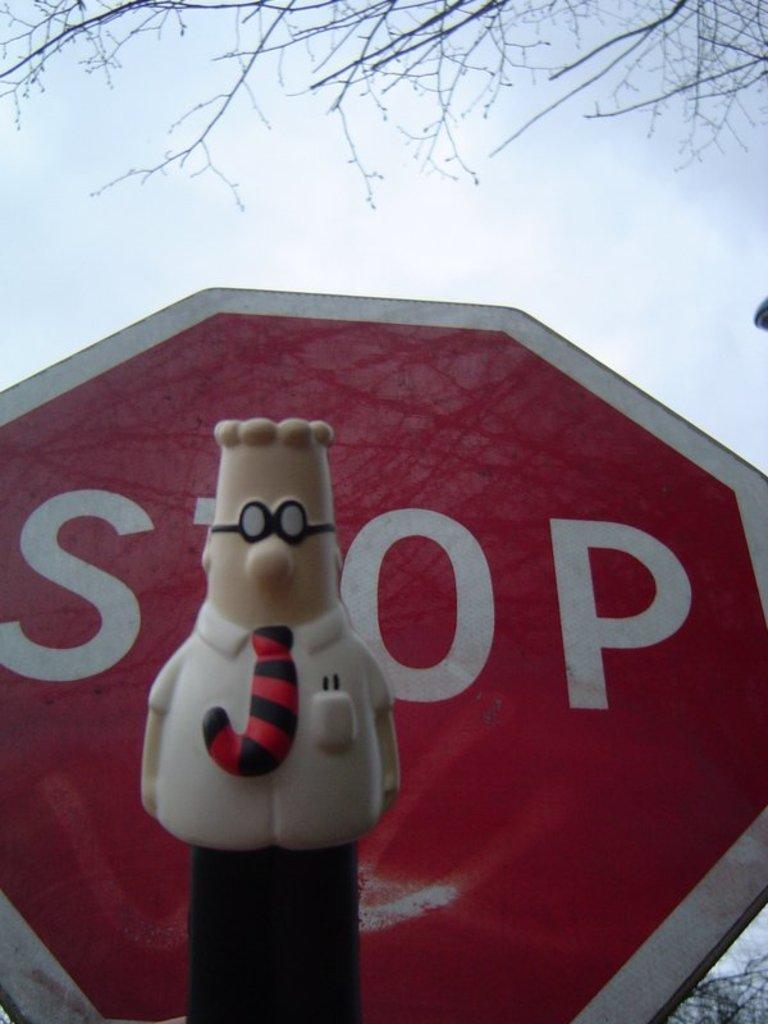In one or two sentences, can you explain what this image depicts? In this image we can see a toy and a sign board. In the background we can see branches of the trees and clouds in the sky. 